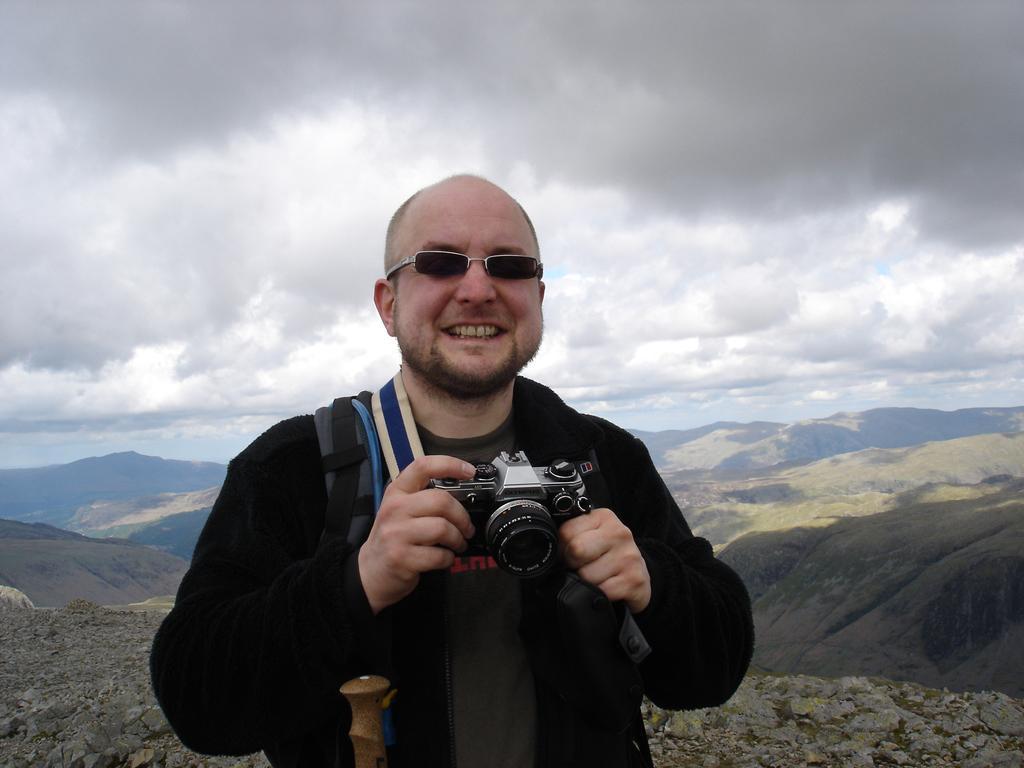In one or two sentences, can you explain what this image depicts? This picture there is a man holding a camera and smiling. He is wearing spectacles. In the background, there were hills and sky with full of Clouds here. 